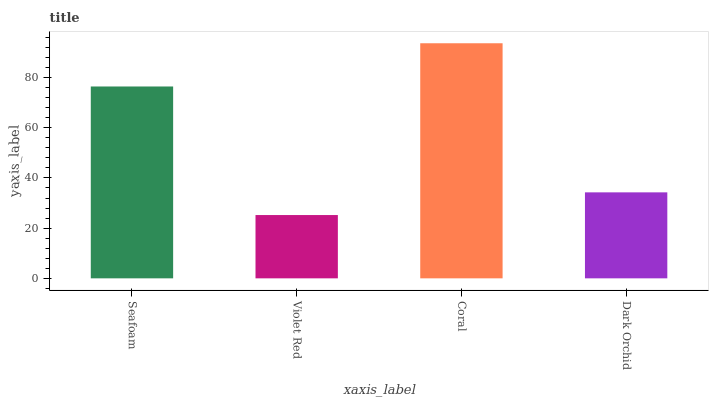Is Violet Red the minimum?
Answer yes or no. Yes. Is Coral the maximum?
Answer yes or no. Yes. Is Coral the minimum?
Answer yes or no. No. Is Violet Red the maximum?
Answer yes or no. No. Is Coral greater than Violet Red?
Answer yes or no. Yes. Is Violet Red less than Coral?
Answer yes or no. Yes. Is Violet Red greater than Coral?
Answer yes or no. No. Is Coral less than Violet Red?
Answer yes or no. No. Is Seafoam the high median?
Answer yes or no. Yes. Is Dark Orchid the low median?
Answer yes or no. Yes. Is Violet Red the high median?
Answer yes or no. No. Is Coral the low median?
Answer yes or no. No. 